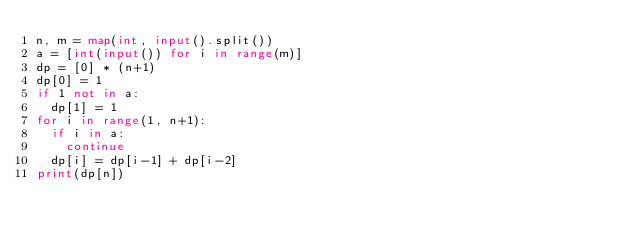Convert code to text. <code><loc_0><loc_0><loc_500><loc_500><_Python_>n, m = map(int, input().split())
a = [int(input()) for i in range(m)]
dp = [0] * (n+1)
dp[0] = 1
if 1 not in a:
  dp[1] = 1
for i in range(1, n+1):
  if i in a:
    continue
  dp[i] = dp[i-1] + dp[i-2]
print(dp[n])
  </code> 